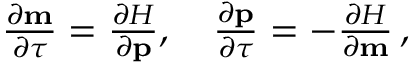Convert formula to latex. <formula><loc_0><loc_0><loc_500><loc_500>\begin{array} { r } { \frac { \partial m } { \partial \tau } = \frac { \partial H } { \partial p } , \quad \frac { \partial p } { \partial \tau } = - \frac { \partial H } { \partial m } \, , } \end{array}</formula> 